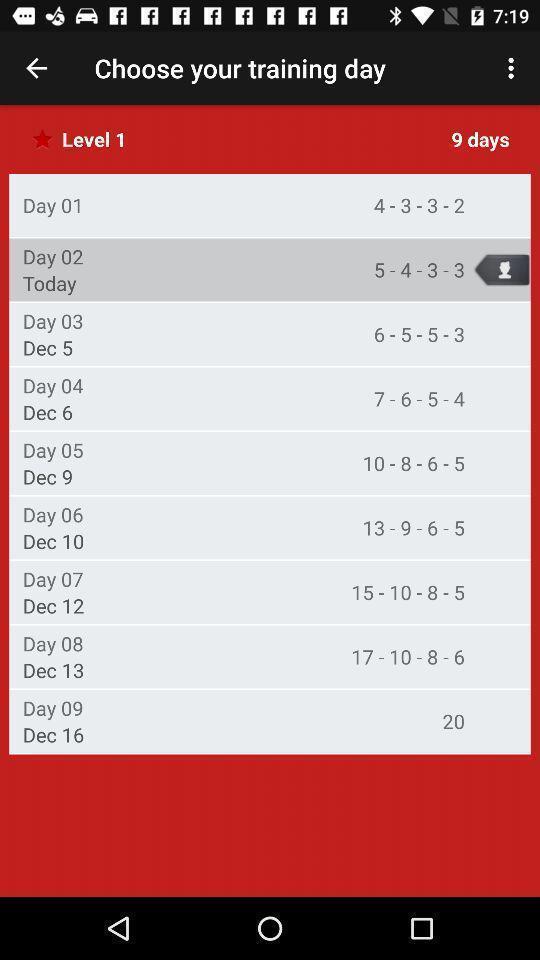Please provide a description for this image. Screen page displaying various dates. 